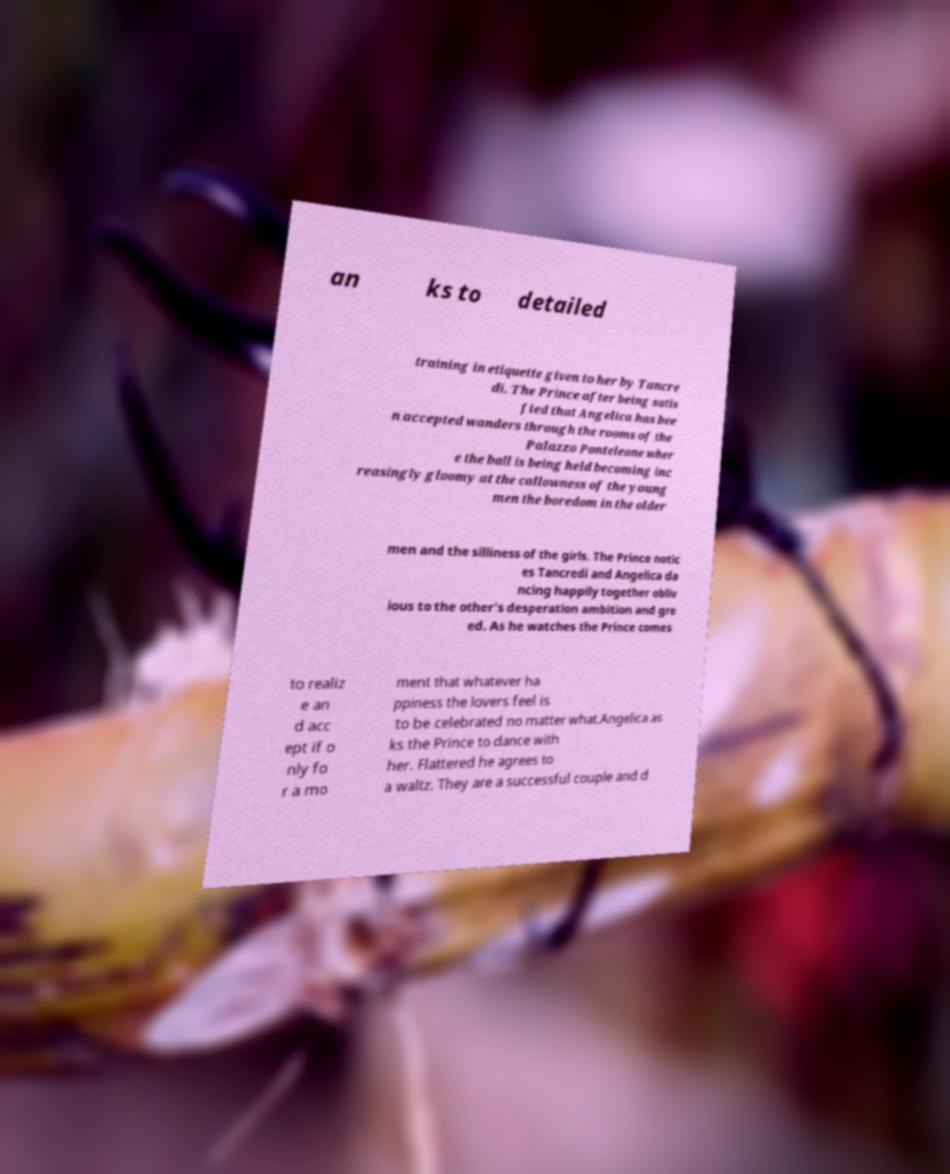Can you accurately transcribe the text from the provided image for me? an ks to detailed training in etiquette given to her by Tancre di. The Prince after being satis fied that Angelica has bee n accepted wanders through the rooms of the Palazzo Ponteleone wher e the ball is being held becoming inc reasingly gloomy at the callowness of the young men the boredom in the older men and the silliness of the girls. The Prince notic es Tancredi and Angelica da ncing happily together obliv ious to the other's desperation ambition and gre ed. As he watches the Prince comes to realiz e an d acc ept if o nly fo r a mo ment that whatever ha ppiness the lovers feel is to be celebrated no matter what.Angelica as ks the Prince to dance with her. Flattered he agrees to a waltz. They are a successful couple and d 